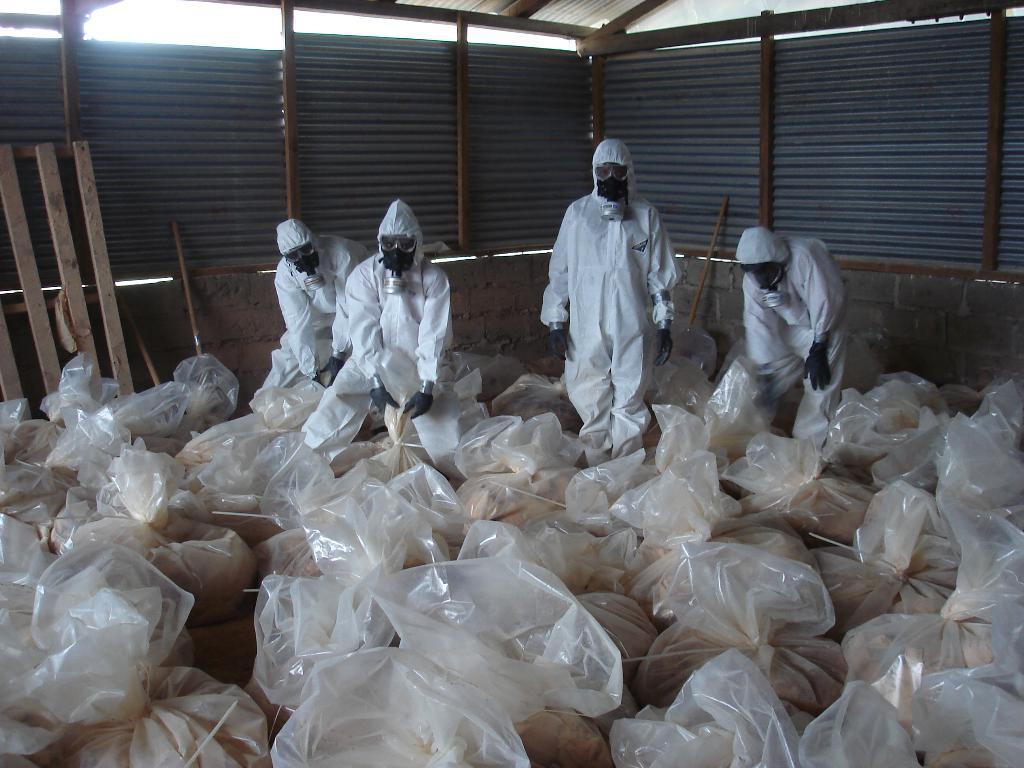In one or two sentences, can you explain what this image depicts? In this image, we can see some people wearing white costumes, we can see some plastic bags on the ground. We can see the tin shed. 